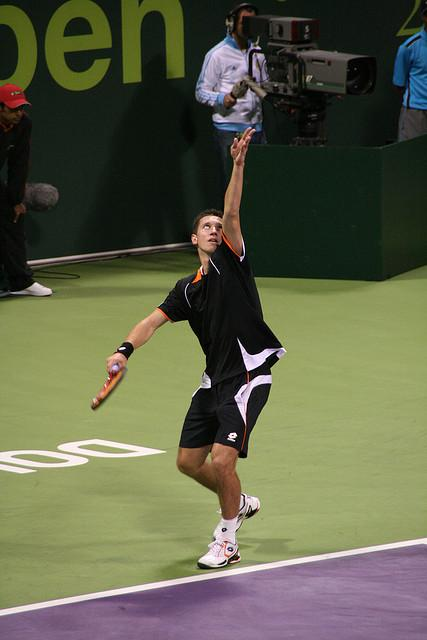What is the player about to do?

Choices:
A) love
B) return
C) serve
D) fake out serve 